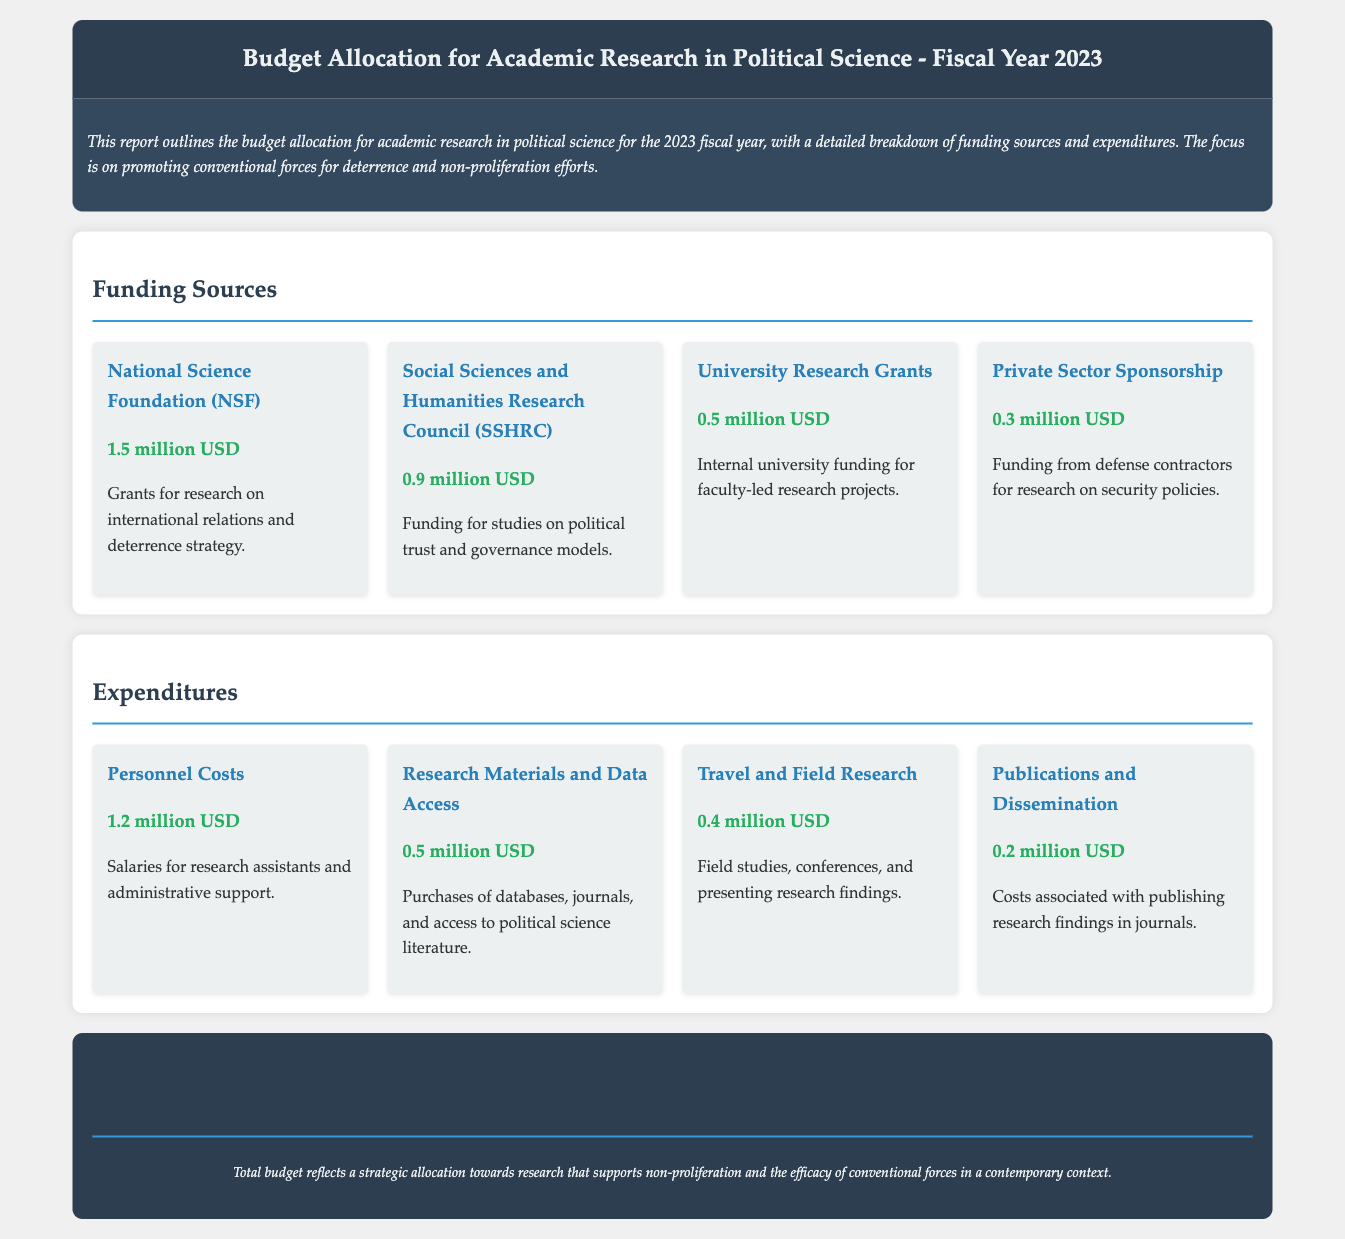What is the total budget for the fiscal year 2023? The total budget is stated explicitly in the document as $4.0 million USD.
Answer: $4.0 million USD How much funding is allocated from the National Science Foundation? The National Science Foundation funding amount is listed in the funding sources section as $1.5 million USD.
Answer: $1.5 million USD What is the expenditure for personnel costs? The expenditure for personnel costs is detailed in the expenditures section as $1.2 million USD.
Answer: $1.2 million USD Which funding source contributes the least amount? The funding source that contributes the least is Private Sector Sponsorship, which is $0.3 million USD.
Answer: Private Sector Sponsorship How much is allocated for research materials and data access? The funding for research materials and data access can be found under expenditures, stated as $0.5 million USD.
Answer: $0.5 million USD What percentage of the total budget is allocated to personnel costs? To find the percentage, divide personnel costs by the total budget: (1.2 million / 4.0 million) * 100 = 30%.
Answer: 30% Which funding body is responsible for grants specifically related to deterrence strategy? The funding body responsible for grants related to deterrence strategy is the National Science Foundation.
Answer: National Science Foundation What is the total amount allocated for publications and dissemination? The total amount for publications and dissemination is specified in the expenditures section as $0.2 million USD.
Answer: $0.2 million USD How much funding is provided by university research grants? The funding from university research grants is presented in the funding sources as $0.5 million USD.
Answer: $0.5 million USD 